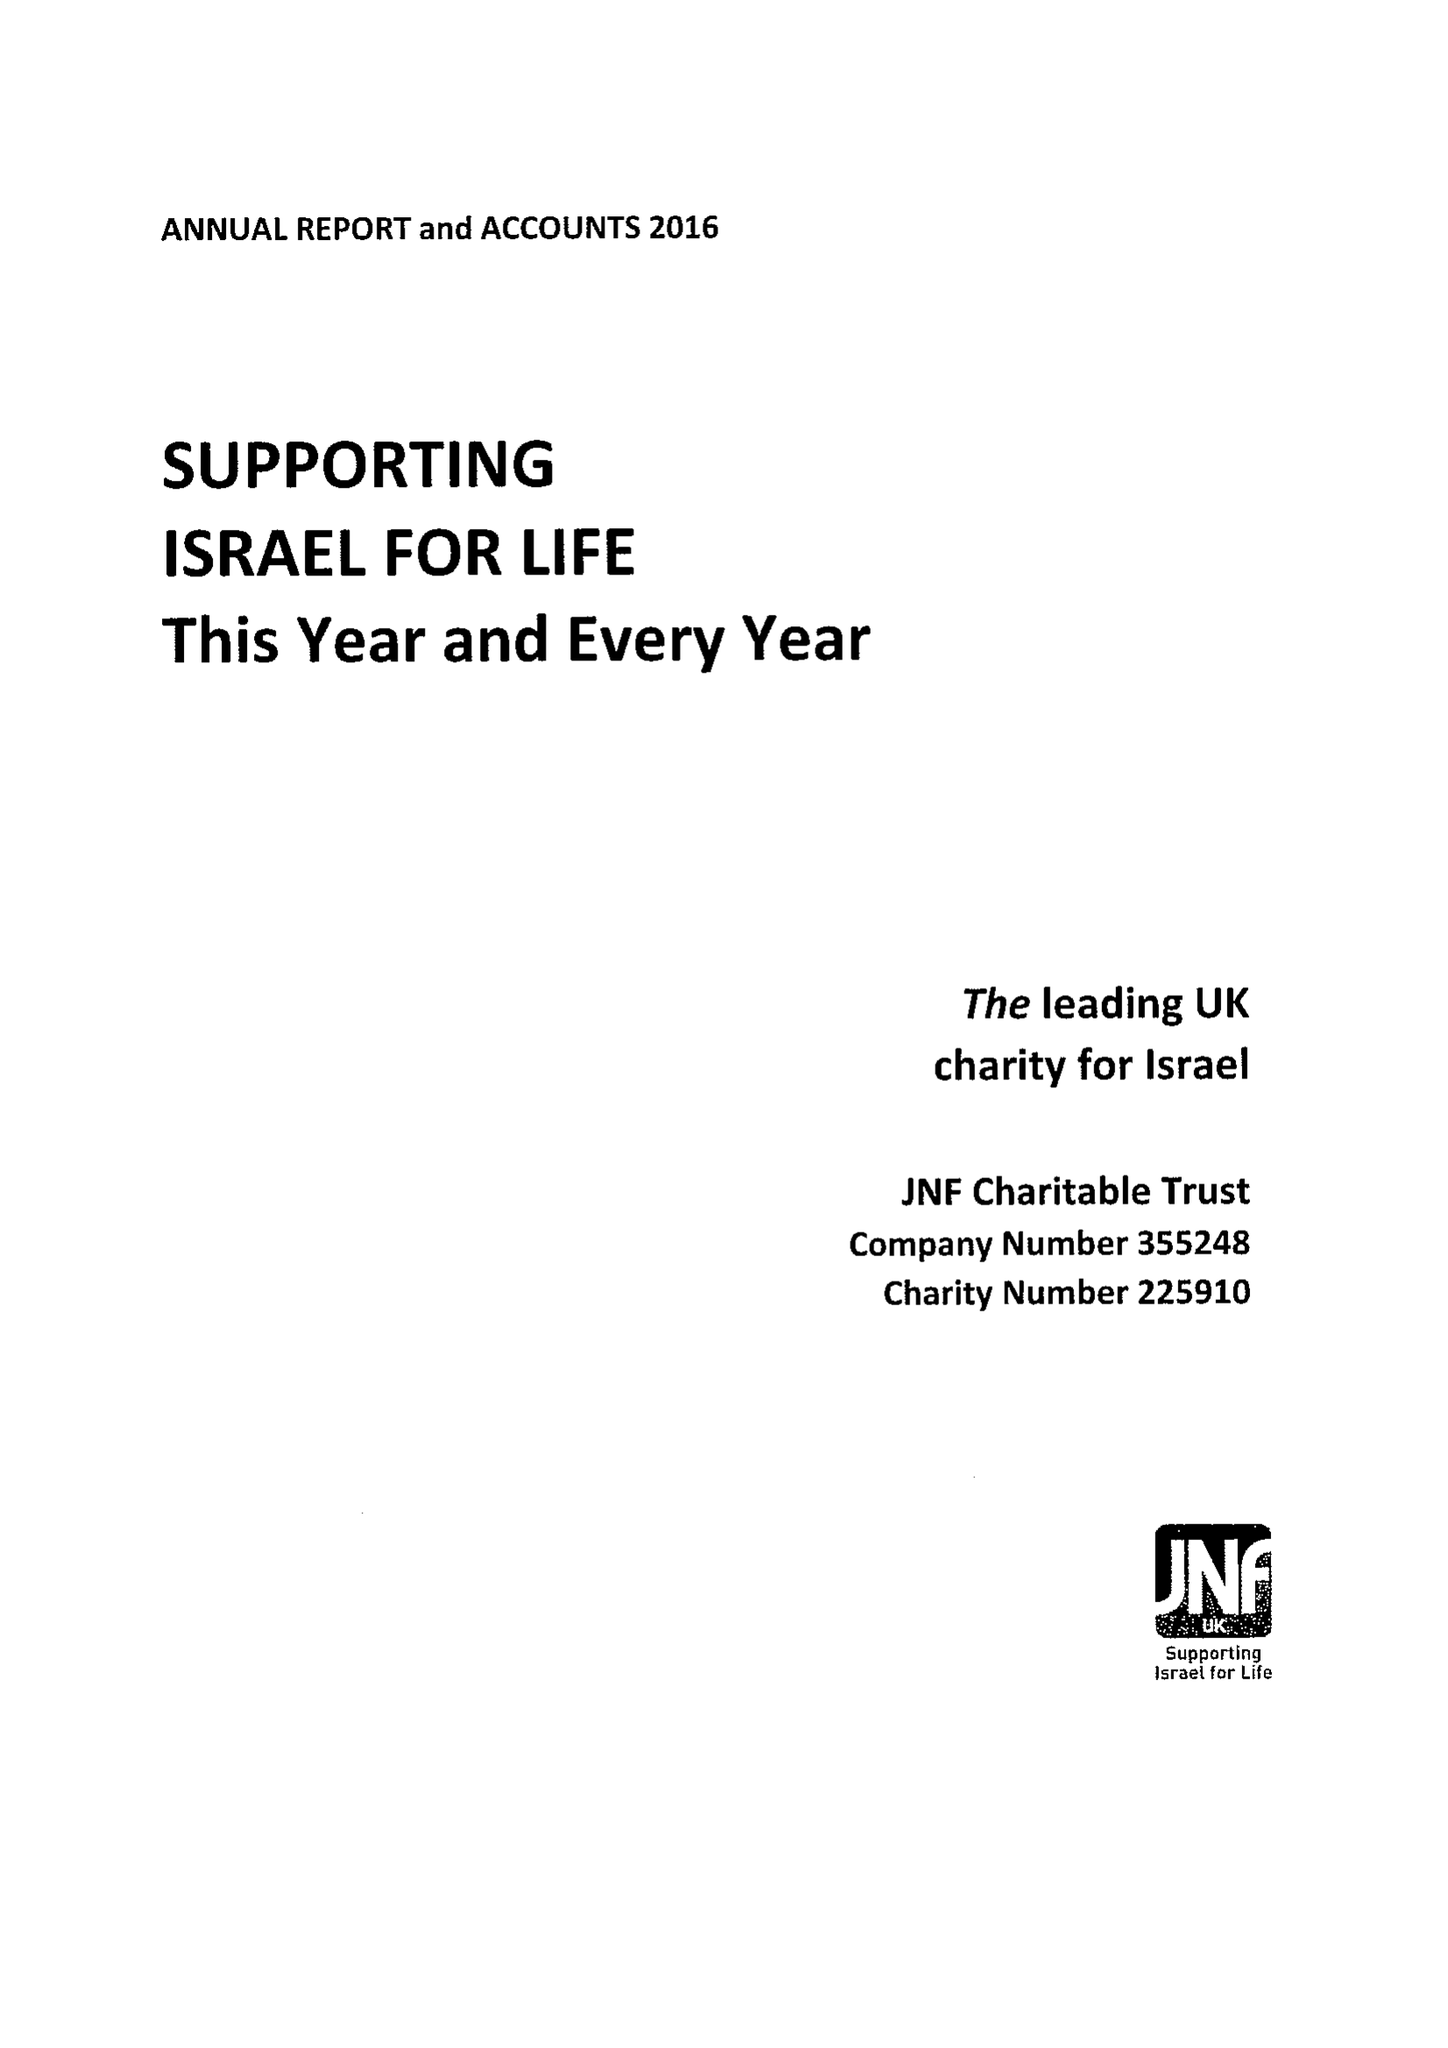What is the value for the address__street_line?
Answer the question using a single word or phrase. 154 BRENT STREET 